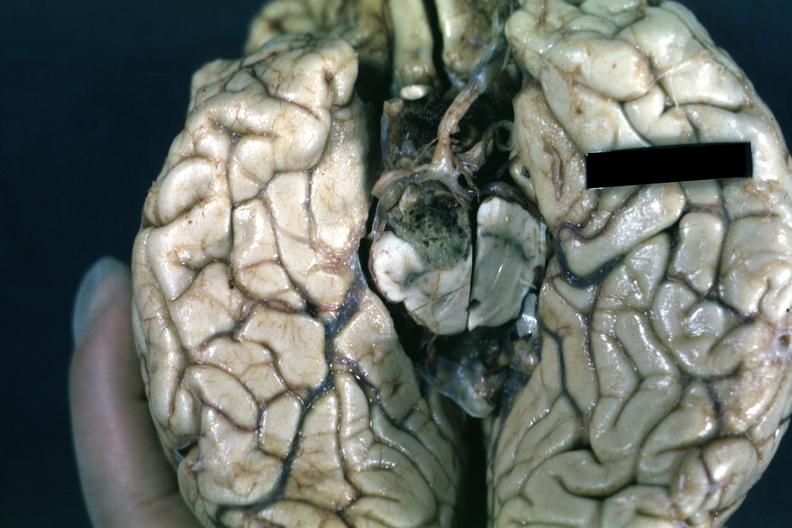s endocrine present?
Answer the question using a single word or phrase. Yes 